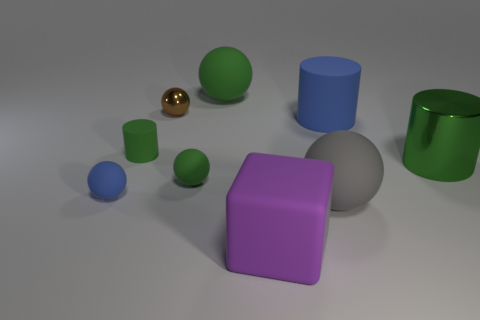Is there any other thing that has the same shape as the purple matte thing?
Keep it short and to the point. No. How many small rubber cylinders are in front of the metal object that is left of the large sphere behind the blue cylinder?
Keep it short and to the point. 1. There is a large object that is both in front of the small blue object and right of the purple rubber object; what is its material?
Offer a very short reply. Rubber. The rubber block has what color?
Give a very brief answer. Purple. Is the number of cylinders left of the metal ball greater than the number of objects that are behind the large matte cylinder?
Your answer should be very brief. No. There is a rubber thing that is behind the brown object; what is its color?
Offer a very short reply. Green. Does the ball that is behind the small metal object have the same size as the brown metal ball that is behind the big metallic cylinder?
Your answer should be very brief. No. What number of objects are gray matte blocks or tiny blue things?
Provide a short and direct response. 1. What material is the green cylinder that is to the right of the metal thing that is to the left of the large gray matte sphere?
Your answer should be very brief. Metal. How many blue objects have the same shape as the gray thing?
Make the answer very short. 1. 